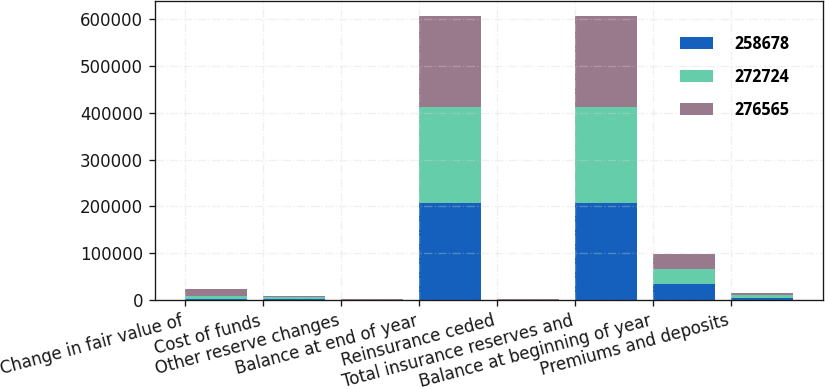Convert chart to OTSL. <chart><loc_0><loc_0><loc_500><loc_500><stacked_bar_chart><ecel><fcel>Change in fair value of<fcel>Cost of funds<fcel>Other reserve changes<fcel>Balance at end of year<fcel>Reinsurance ceded<fcel>Total insurance reserves and<fcel>Balance at beginning of year<fcel>Premiums and deposits<nl><fcel>258678<fcel>2255<fcel>2724<fcel>85<fcel>208333<fcel>361<fcel>207972<fcel>33536<fcel>4974<nl><fcel>272724<fcel>6390<fcel>2781<fcel>80<fcel>204627<fcel>353<fcel>204374<fcel>32810<fcel>4806<nl><fcel>276565<fcel>14482<fcel>2837<fcel>917<fcel>195493<fcel>366<fcel>195127<fcel>32176<fcel>4862<nl></chart> 